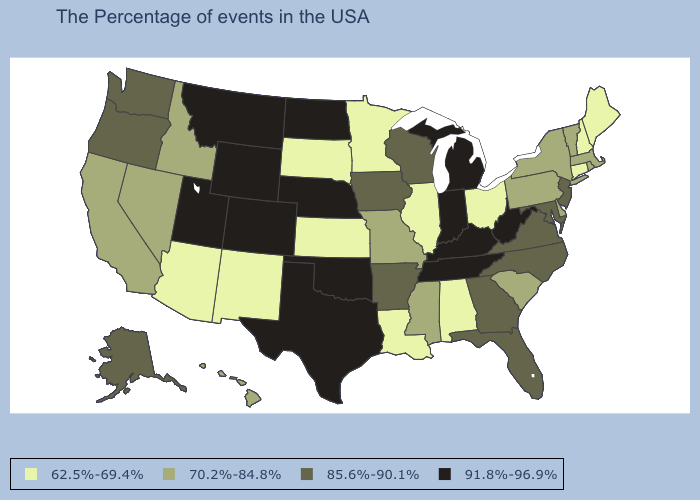Among the states that border Alabama , does Florida have the highest value?
Keep it brief. No. Which states have the highest value in the USA?
Answer briefly. West Virginia, Michigan, Kentucky, Indiana, Tennessee, Nebraska, Oklahoma, Texas, North Dakota, Wyoming, Colorado, Utah, Montana. What is the value of North Dakota?
Answer briefly. 91.8%-96.9%. Is the legend a continuous bar?
Quick response, please. No. Does Indiana have the lowest value in the MidWest?
Keep it brief. No. Name the states that have a value in the range 85.6%-90.1%?
Write a very short answer. New Jersey, Maryland, Virginia, North Carolina, Florida, Georgia, Wisconsin, Arkansas, Iowa, Washington, Oregon, Alaska. Name the states that have a value in the range 85.6%-90.1%?
Quick response, please. New Jersey, Maryland, Virginia, North Carolina, Florida, Georgia, Wisconsin, Arkansas, Iowa, Washington, Oregon, Alaska. Which states have the lowest value in the USA?
Quick response, please. Maine, New Hampshire, Connecticut, Ohio, Alabama, Illinois, Louisiana, Minnesota, Kansas, South Dakota, New Mexico, Arizona. Does the first symbol in the legend represent the smallest category?
Answer briefly. Yes. What is the highest value in the USA?
Answer briefly. 91.8%-96.9%. What is the value of Washington?
Answer briefly. 85.6%-90.1%. What is the value of New Jersey?
Write a very short answer. 85.6%-90.1%. Does Pennsylvania have the same value as Delaware?
Keep it brief. Yes. What is the value of Mississippi?
Answer briefly. 70.2%-84.8%. Does Illinois have the same value as Alabama?
Quick response, please. Yes. 